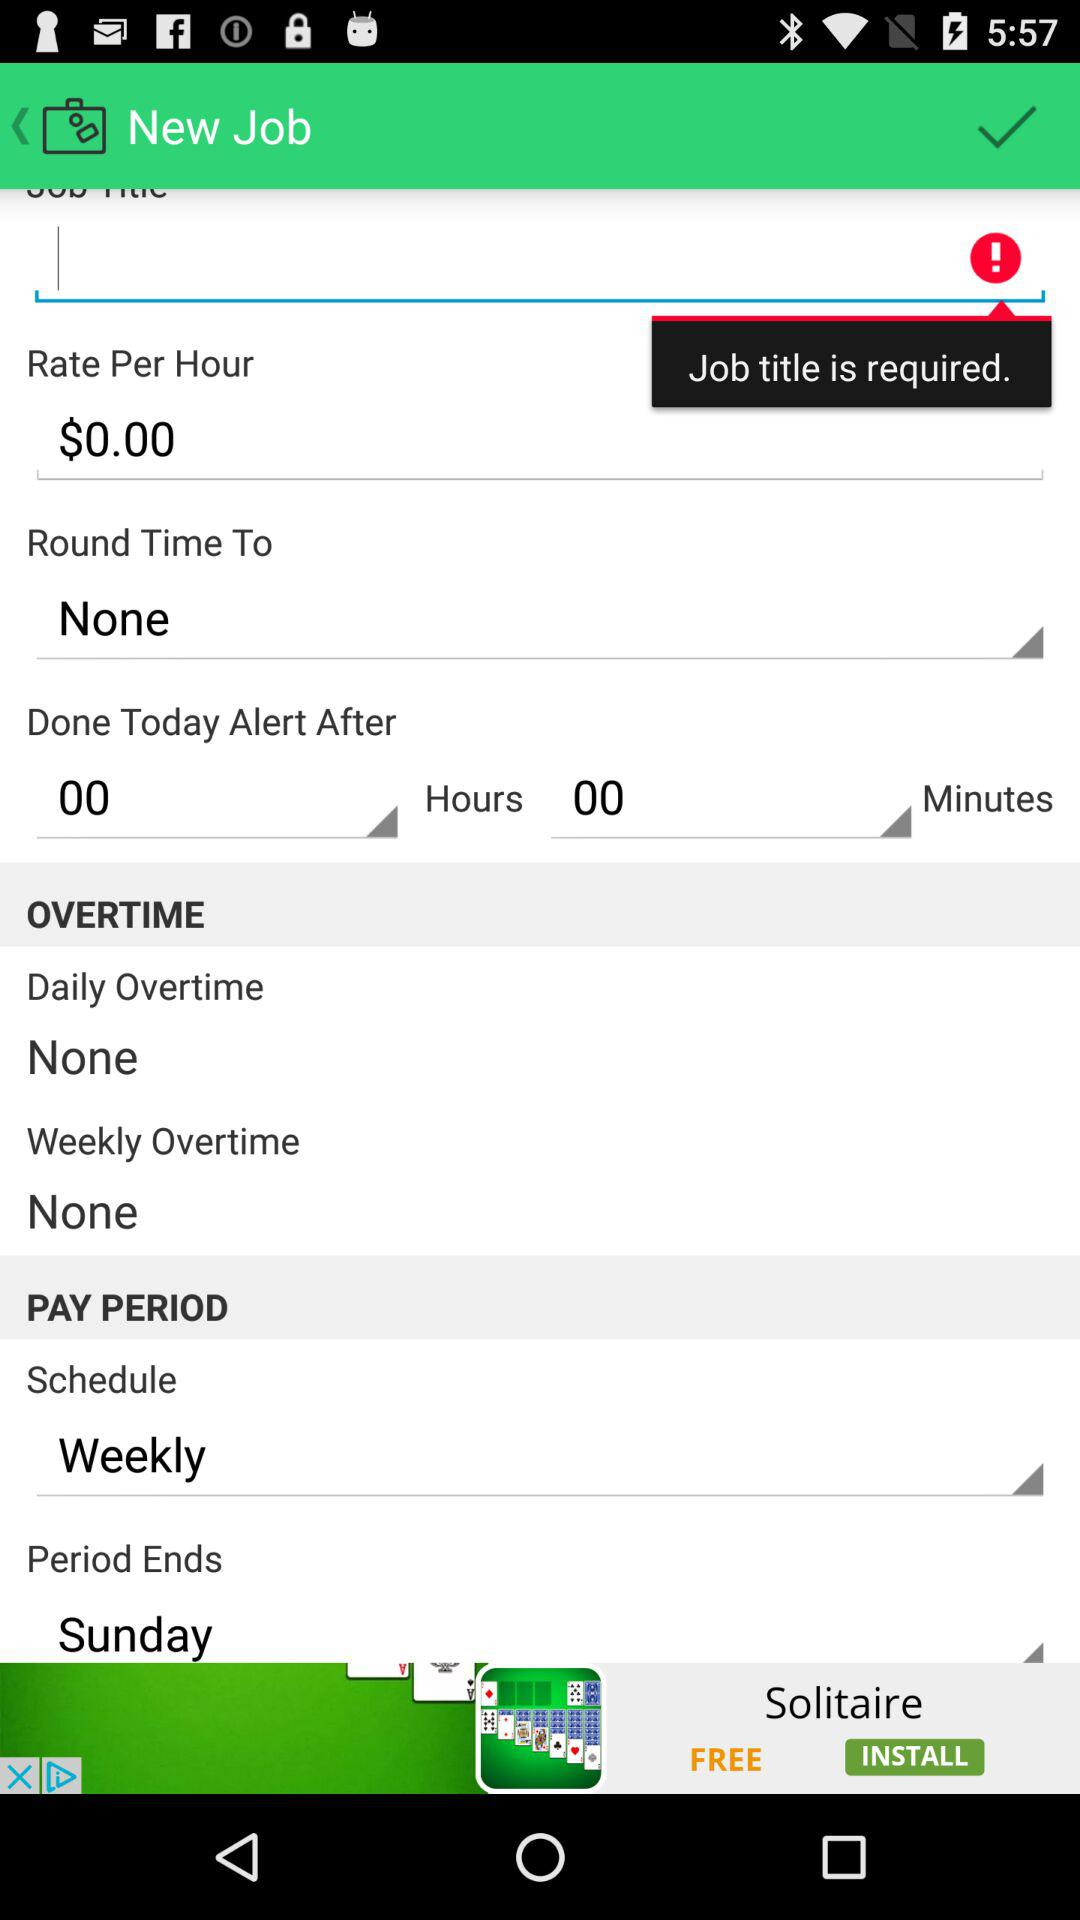What is the pay period schedule? The pay period schedule is weekly. 